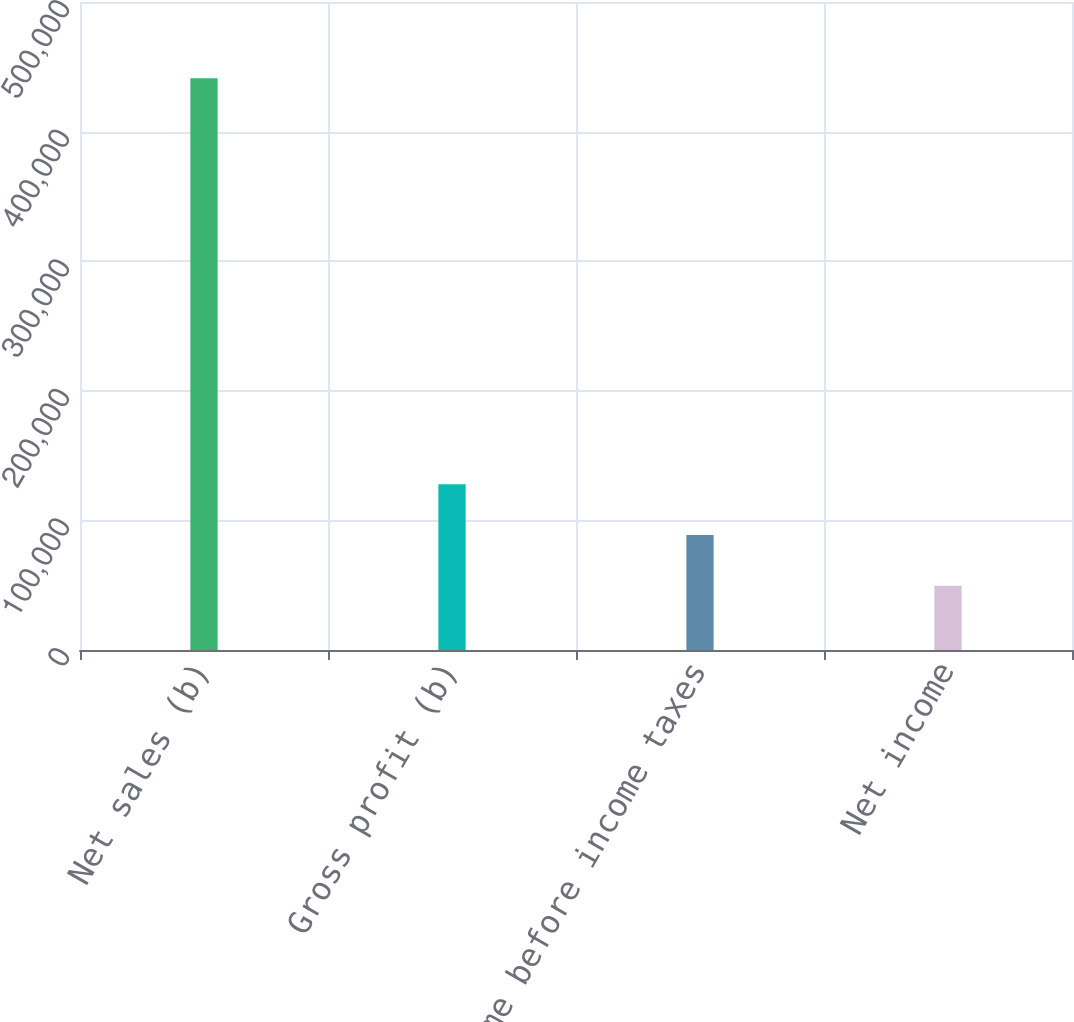<chart> <loc_0><loc_0><loc_500><loc_500><bar_chart><fcel>Net sales (b)<fcel>Gross profit (b)<fcel>Income before income taxes<fcel>Net income<nl><fcel>441141<fcel>127888<fcel>88731.6<fcel>49575<nl></chart> 